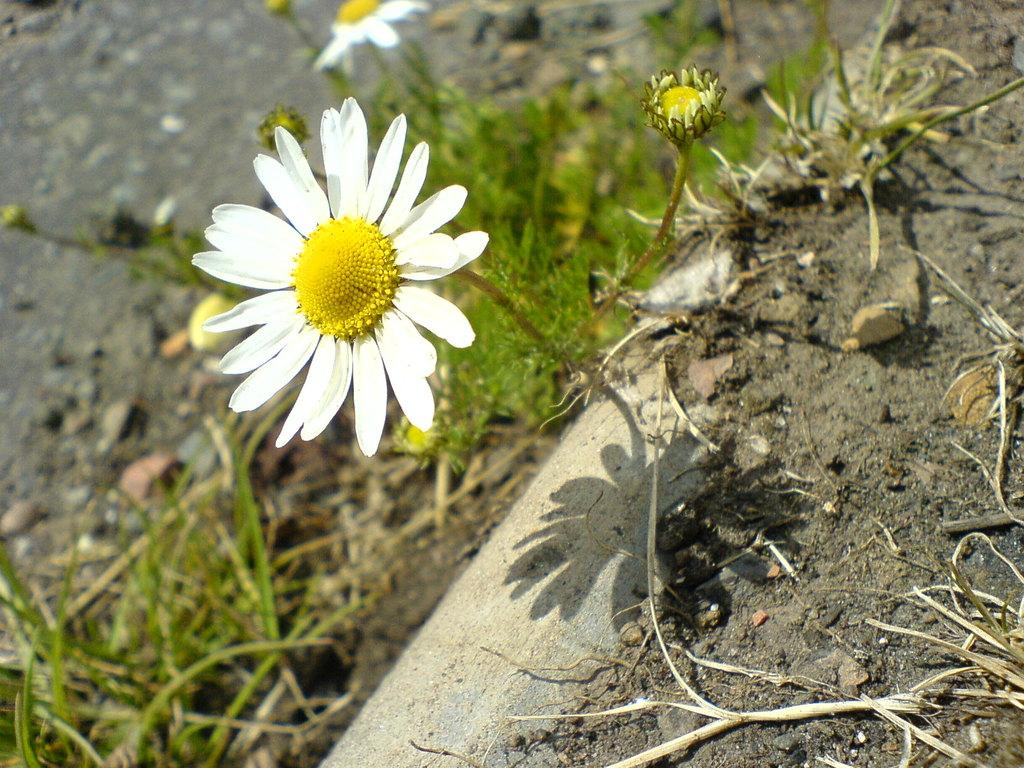What type of vegetation is present in the image? There are flowers and plants in the image. What other elements can be seen in the image? There are stones and soil visible in the image. What is the ground like in the background of the image? The ground is visible in the background of the image. What year is depicted in the image? The image does not depict a specific year; it is a still image of flowers, plants, stones, and soil. What scene is being acted out in the image? The image is not a scene from a play or movie; it is a still image of flowers, plants, stones, and soil. 